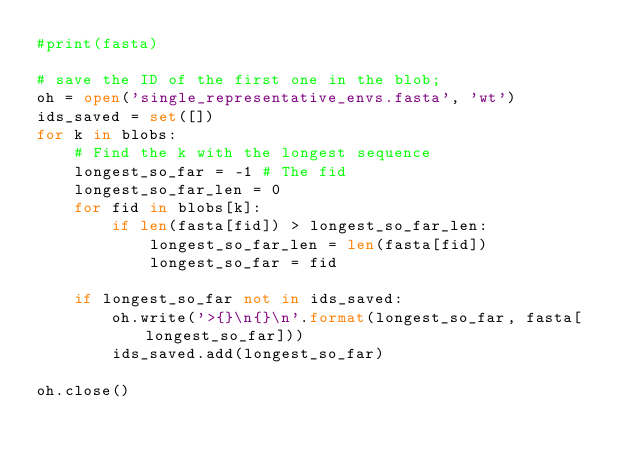Convert code to text. <code><loc_0><loc_0><loc_500><loc_500><_Python_>#print(fasta)

# save the ID of the first one in the blob;
oh = open('single_representative_envs.fasta', 'wt')
ids_saved = set([])
for k in blobs:
    # Find the k with the longest sequence
    longest_so_far = -1 # The fid
    longest_so_far_len = 0
    for fid in blobs[k]:
        if len(fasta[fid]) > longest_so_far_len:
            longest_so_far_len = len(fasta[fid])
            longest_so_far = fid

    if longest_so_far not in ids_saved:
        oh.write('>{}\n{}\n'.format(longest_so_far, fasta[longest_so_far]))
        ids_saved.add(longest_so_far)

oh.close()
</code> 